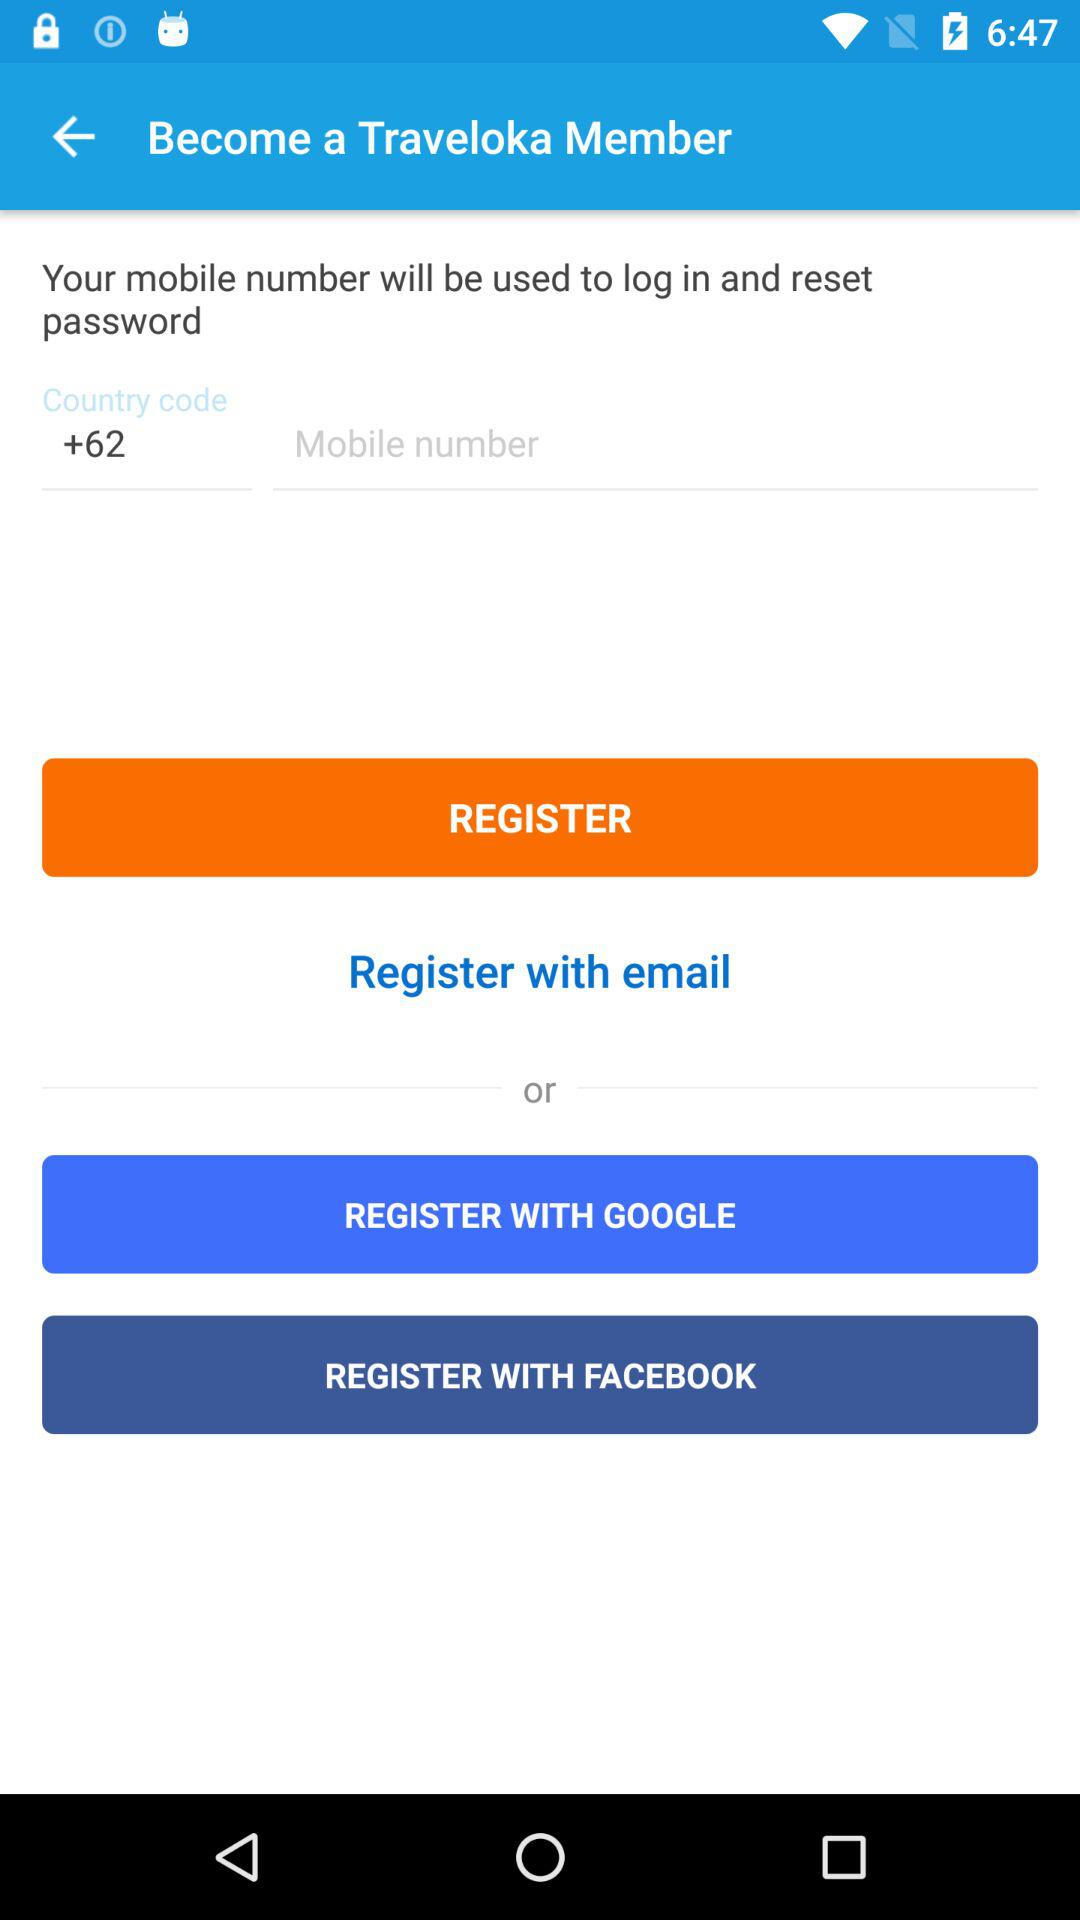What is the country code? The country code is +62. 